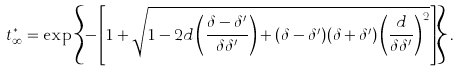<formula> <loc_0><loc_0><loc_500><loc_500>t _ { \infty } ^ { * } = \exp \left \{ - \left [ 1 + \sqrt { 1 - 2 d \left ( \frac { \delta - \delta ^ { \prime } } { \delta \delta ^ { \prime } } \right ) + ( \delta - \delta ^ { \prime } ) ( \delta + \delta ^ { \prime } ) \left ( \frac { d } { \delta \delta ^ { \prime } } \right ) ^ { 2 } } \right ] \right \} .</formula> 